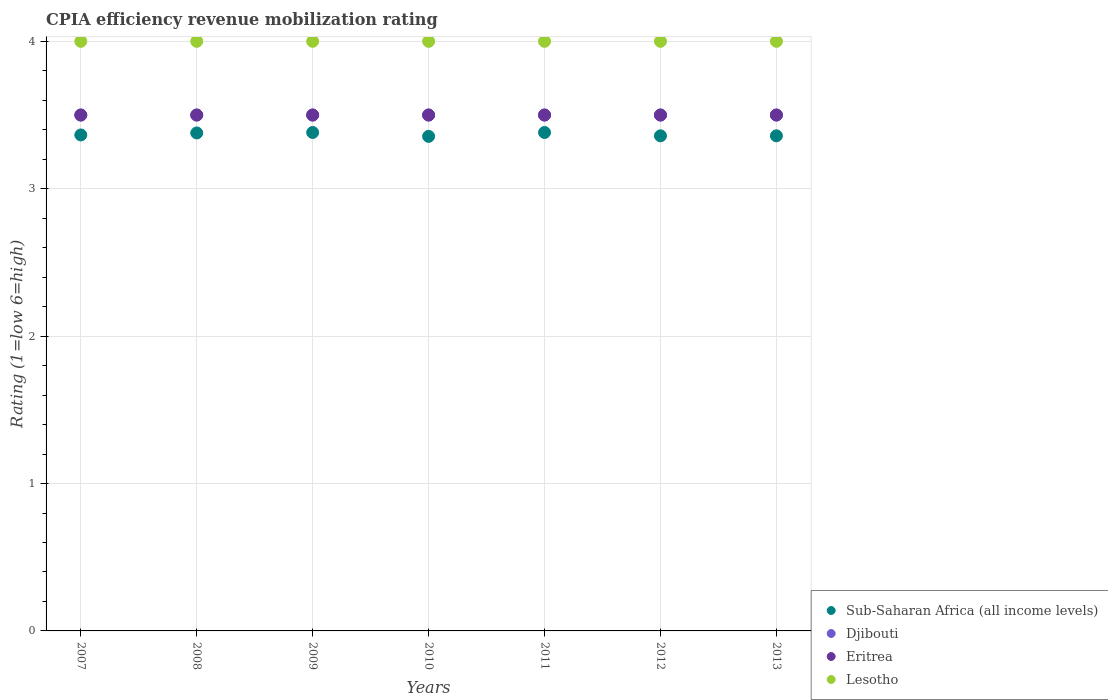How many different coloured dotlines are there?
Keep it short and to the point. 4. Is the number of dotlines equal to the number of legend labels?
Give a very brief answer. Yes. What is the CPIA rating in Djibouti in 2009?
Keep it short and to the point. 3.5. Across all years, what is the maximum CPIA rating in Lesotho?
Offer a very short reply. 4. What is the total CPIA rating in Lesotho in the graph?
Offer a very short reply. 28. What is the difference between the CPIA rating in Sub-Saharan Africa (all income levels) in 2008 and that in 2010?
Ensure brevity in your answer.  0.02. What is the average CPIA rating in Eritrea per year?
Offer a terse response. 3.5. In the year 2010, what is the difference between the CPIA rating in Sub-Saharan Africa (all income levels) and CPIA rating in Lesotho?
Your response must be concise. -0.64. In how many years, is the CPIA rating in Eritrea greater than 1.6?
Offer a very short reply. 7. Is the CPIA rating in Lesotho in 2010 less than that in 2013?
Offer a very short reply. No. Is the difference between the CPIA rating in Sub-Saharan Africa (all income levels) in 2010 and 2012 greater than the difference between the CPIA rating in Lesotho in 2010 and 2012?
Make the answer very short. No. What is the difference between the highest and the second highest CPIA rating in Eritrea?
Offer a very short reply. 0. In how many years, is the CPIA rating in Sub-Saharan Africa (all income levels) greater than the average CPIA rating in Sub-Saharan Africa (all income levels) taken over all years?
Offer a terse response. 3. Is the sum of the CPIA rating in Djibouti in 2012 and 2013 greater than the maximum CPIA rating in Eritrea across all years?
Offer a very short reply. Yes. Is it the case that in every year, the sum of the CPIA rating in Eritrea and CPIA rating in Djibouti  is greater than the CPIA rating in Sub-Saharan Africa (all income levels)?
Ensure brevity in your answer.  Yes. How many years are there in the graph?
Keep it short and to the point. 7. Are the values on the major ticks of Y-axis written in scientific E-notation?
Ensure brevity in your answer.  No. Does the graph contain any zero values?
Your answer should be very brief. No. Does the graph contain grids?
Give a very brief answer. Yes. Where does the legend appear in the graph?
Ensure brevity in your answer.  Bottom right. How are the legend labels stacked?
Make the answer very short. Vertical. What is the title of the graph?
Offer a very short reply. CPIA efficiency revenue mobilization rating. What is the label or title of the Y-axis?
Provide a succinct answer. Rating (1=low 6=high). What is the Rating (1=low 6=high) of Sub-Saharan Africa (all income levels) in 2007?
Give a very brief answer. 3.36. What is the Rating (1=low 6=high) in Djibouti in 2007?
Make the answer very short. 3.5. What is the Rating (1=low 6=high) in Lesotho in 2007?
Offer a very short reply. 4. What is the Rating (1=low 6=high) in Sub-Saharan Africa (all income levels) in 2008?
Give a very brief answer. 3.38. What is the Rating (1=low 6=high) in Djibouti in 2008?
Keep it short and to the point. 3.5. What is the Rating (1=low 6=high) in Sub-Saharan Africa (all income levels) in 2009?
Make the answer very short. 3.38. What is the Rating (1=low 6=high) of Eritrea in 2009?
Provide a short and direct response. 3.5. What is the Rating (1=low 6=high) in Sub-Saharan Africa (all income levels) in 2010?
Your answer should be compact. 3.36. What is the Rating (1=low 6=high) in Eritrea in 2010?
Your answer should be compact. 3.5. What is the Rating (1=low 6=high) in Lesotho in 2010?
Your response must be concise. 4. What is the Rating (1=low 6=high) in Sub-Saharan Africa (all income levels) in 2011?
Your answer should be compact. 3.38. What is the Rating (1=low 6=high) of Djibouti in 2011?
Your answer should be very brief. 3.5. What is the Rating (1=low 6=high) in Eritrea in 2011?
Your answer should be very brief. 3.5. What is the Rating (1=low 6=high) of Sub-Saharan Africa (all income levels) in 2012?
Offer a very short reply. 3.36. What is the Rating (1=low 6=high) in Eritrea in 2012?
Provide a short and direct response. 3.5. What is the Rating (1=low 6=high) of Lesotho in 2012?
Give a very brief answer. 4. What is the Rating (1=low 6=high) of Sub-Saharan Africa (all income levels) in 2013?
Offer a very short reply. 3.36. What is the Rating (1=low 6=high) in Lesotho in 2013?
Make the answer very short. 4. Across all years, what is the maximum Rating (1=low 6=high) in Sub-Saharan Africa (all income levels)?
Give a very brief answer. 3.38. Across all years, what is the maximum Rating (1=low 6=high) in Djibouti?
Your answer should be compact. 3.5. Across all years, what is the maximum Rating (1=low 6=high) of Eritrea?
Your response must be concise. 3.5. Across all years, what is the maximum Rating (1=low 6=high) of Lesotho?
Offer a very short reply. 4. Across all years, what is the minimum Rating (1=low 6=high) of Sub-Saharan Africa (all income levels)?
Your answer should be very brief. 3.36. Across all years, what is the minimum Rating (1=low 6=high) in Djibouti?
Make the answer very short. 3.5. Across all years, what is the minimum Rating (1=low 6=high) in Eritrea?
Your answer should be compact. 3.5. Across all years, what is the minimum Rating (1=low 6=high) in Lesotho?
Your answer should be compact. 4. What is the total Rating (1=low 6=high) in Sub-Saharan Africa (all income levels) in the graph?
Ensure brevity in your answer.  23.58. What is the total Rating (1=low 6=high) of Eritrea in the graph?
Provide a short and direct response. 24.5. What is the difference between the Rating (1=low 6=high) in Sub-Saharan Africa (all income levels) in 2007 and that in 2008?
Offer a terse response. -0.01. What is the difference between the Rating (1=low 6=high) of Djibouti in 2007 and that in 2008?
Make the answer very short. 0. What is the difference between the Rating (1=low 6=high) of Eritrea in 2007 and that in 2008?
Offer a very short reply. 0. What is the difference between the Rating (1=low 6=high) in Lesotho in 2007 and that in 2008?
Give a very brief answer. 0. What is the difference between the Rating (1=low 6=high) in Sub-Saharan Africa (all income levels) in 2007 and that in 2009?
Provide a short and direct response. -0.02. What is the difference between the Rating (1=low 6=high) of Lesotho in 2007 and that in 2009?
Keep it short and to the point. 0. What is the difference between the Rating (1=low 6=high) of Sub-Saharan Africa (all income levels) in 2007 and that in 2010?
Your answer should be compact. 0.01. What is the difference between the Rating (1=low 6=high) of Djibouti in 2007 and that in 2010?
Provide a succinct answer. 0. What is the difference between the Rating (1=low 6=high) of Eritrea in 2007 and that in 2010?
Provide a succinct answer. 0. What is the difference between the Rating (1=low 6=high) of Lesotho in 2007 and that in 2010?
Your answer should be compact. 0. What is the difference between the Rating (1=low 6=high) of Sub-Saharan Africa (all income levels) in 2007 and that in 2011?
Offer a very short reply. -0.02. What is the difference between the Rating (1=low 6=high) in Lesotho in 2007 and that in 2011?
Your response must be concise. 0. What is the difference between the Rating (1=low 6=high) in Sub-Saharan Africa (all income levels) in 2007 and that in 2012?
Provide a succinct answer. 0.01. What is the difference between the Rating (1=low 6=high) in Djibouti in 2007 and that in 2012?
Offer a terse response. 0. What is the difference between the Rating (1=low 6=high) of Lesotho in 2007 and that in 2012?
Offer a very short reply. 0. What is the difference between the Rating (1=low 6=high) of Sub-Saharan Africa (all income levels) in 2007 and that in 2013?
Provide a succinct answer. 0.01. What is the difference between the Rating (1=low 6=high) of Sub-Saharan Africa (all income levels) in 2008 and that in 2009?
Make the answer very short. -0. What is the difference between the Rating (1=low 6=high) in Djibouti in 2008 and that in 2009?
Make the answer very short. 0. What is the difference between the Rating (1=low 6=high) in Eritrea in 2008 and that in 2009?
Your response must be concise. 0. What is the difference between the Rating (1=low 6=high) of Sub-Saharan Africa (all income levels) in 2008 and that in 2010?
Make the answer very short. 0.02. What is the difference between the Rating (1=low 6=high) in Eritrea in 2008 and that in 2010?
Offer a very short reply. 0. What is the difference between the Rating (1=low 6=high) of Lesotho in 2008 and that in 2010?
Give a very brief answer. 0. What is the difference between the Rating (1=low 6=high) of Sub-Saharan Africa (all income levels) in 2008 and that in 2011?
Keep it short and to the point. -0. What is the difference between the Rating (1=low 6=high) of Eritrea in 2008 and that in 2011?
Make the answer very short. 0. What is the difference between the Rating (1=low 6=high) of Sub-Saharan Africa (all income levels) in 2008 and that in 2012?
Provide a succinct answer. 0.02. What is the difference between the Rating (1=low 6=high) in Eritrea in 2008 and that in 2012?
Keep it short and to the point. 0. What is the difference between the Rating (1=low 6=high) in Lesotho in 2008 and that in 2012?
Give a very brief answer. 0. What is the difference between the Rating (1=low 6=high) of Sub-Saharan Africa (all income levels) in 2008 and that in 2013?
Make the answer very short. 0.02. What is the difference between the Rating (1=low 6=high) of Djibouti in 2008 and that in 2013?
Keep it short and to the point. 0. What is the difference between the Rating (1=low 6=high) of Lesotho in 2008 and that in 2013?
Ensure brevity in your answer.  0. What is the difference between the Rating (1=low 6=high) in Sub-Saharan Africa (all income levels) in 2009 and that in 2010?
Give a very brief answer. 0.03. What is the difference between the Rating (1=low 6=high) in Lesotho in 2009 and that in 2010?
Provide a short and direct response. 0. What is the difference between the Rating (1=low 6=high) in Sub-Saharan Africa (all income levels) in 2009 and that in 2012?
Give a very brief answer. 0.02. What is the difference between the Rating (1=low 6=high) of Lesotho in 2009 and that in 2012?
Offer a terse response. 0. What is the difference between the Rating (1=low 6=high) of Sub-Saharan Africa (all income levels) in 2009 and that in 2013?
Provide a short and direct response. 0.02. What is the difference between the Rating (1=low 6=high) in Eritrea in 2009 and that in 2013?
Your response must be concise. 0. What is the difference between the Rating (1=low 6=high) in Lesotho in 2009 and that in 2013?
Keep it short and to the point. 0. What is the difference between the Rating (1=low 6=high) of Sub-Saharan Africa (all income levels) in 2010 and that in 2011?
Offer a terse response. -0.03. What is the difference between the Rating (1=low 6=high) of Sub-Saharan Africa (all income levels) in 2010 and that in 2012?
Offer a very short reply. -0. What is the difference between the Rating (1=low 6=high) of Djibouti in 2010 and that in 2012?
Give a very brief answer. 0. What is the difference between the Rating (1=low 6=high) in Eritrea in 2010 and that in 2012?
Your answer should be very brief. 0. What is the difference between the Rating (1=low 6=high) in Sub-Saharan Africa (all income levels) in 2010 and that in 2013?
Provide a succinct answer. -0. What is the difference between the Rating (1=low 6=high) of Lesotho in 2010 and that in 2013?
Provide a succinct answer. 0. What is the difference between the Rating (1=low 6=high) in Sub-Saharan Africa (all income levels) in 2011 and that in 2012?
Make the answer very short. 0.02. What is the difference between the Rating (1=low 6=high) of Djibouti in 2011 and that in 2012?
Make the answer very short. 0. What is the difference between the Rating (1=low 6=high) in Eritrea in 2011 and that in 2012?
Your answer should be compact. 0. What is the difference between the Rating (1=low 6=high) of Sub-Saharan Africa (all income levels) in 2011 and that in 2013?
Offer a terse response. 0.02. What is the difference between the Rating (1=low 6=high) of Djibouti in 2011 and that in 2013?
Your response must be concise. 0. What is the difference between the Rating (1=low 6=high) of Lesotho in 2011 and that in 2013?
Provide a short and direct response. 0. What is the difference between the Rating (1=low 6=high) of Sub-Saharan Africa (all income levels) in 2012 and that in 2013?
Your response must be concise. 0. What is the difference between the Rating (1=low 6=high) of Djibouti in 2012 and that in 2013?
Ensure brevity in your answer.  0. What is the difference between the Rating (1=low 6=high) of Lesotho in 2012 and that in 2013?
Offer a very short reply. 0. What is the difference between the Rating (1=low 6=high) in Sub-Saharan Africa (all income levels) in 2007 and the Rating (1=low 6=high) in Djibouti in 2008?
Offer a very short reply. -0.14. What is the difference between the Rating (1=low 6=high) in Sub-Saharan Africa (all income levels) in 2007 and the Rating (1=low 6=high) in Eritrea in 2008?
Ensure brevity in your answer.  -0.14. What is the difference between the Rating (1=low 6=high) of Sub-Saharan Africa (all income levels) in 2007 and the Rating (1=low 6=high) of Lesotho in 2008?
Your answer should be very brief. -0.64. What is the difference between the Rating (1=low 6=high) in Djibouti in 2007 and the Rating (1=low 6=high) in Lesotho in 2008?
Provide a short and direct response. -0.5. What is the difference between the Rating (1=low 6=high) of Eritrea in 2007 and the Rating (1=low 6=high) of Lesotho in 2008?
Provide a succinct answer. -0.5. What is the difference between the Rating (1=low 6=high) in Sub-Saharan Africa (all income levels) in 2007 and the Rating (1=low 6=high) in Djibouti in 2009?
Your response must be concise. -0.14. What is the difference between the Rating (1=low 6=high) in Sub-Saharan Africa (all income levels) in 2007 and the Rating (1=low 6=high) in Eritrea in 2009?
Ensure brevity in your answer.  -0.14. What is the difference between the Rating (1=low 6=high) of Sub-Saharan Africa (all income levels) in 2007 and the Rating (1=low 6=high) of Lesotho in 2009?
Your answer should be very brief. -0.64. What is the difference between the Rating (1=low 6=high) in Djibouti in 2007 and the Rating (1=low 6=high) in Eritrea in 2009?
Offer a very short reply. 0. What is the difference between the Rating (1=low 6=high) in Djibouti in 2007 and the Rating (1=low 6=high) in Lesotho in 2009?
Keep it short and to the point. -0.5. What is the difference between the Rating (1=low 6=high) of Sub-Saharan Africa (all income levels) in 2007 and the Rating (1=low 6=high) of Djibouti in 2010?
Your answer should be compact. -0.14. What is the difference between the Rating (1=low 6=high) of Sub-Saharan Africa (all income levels) in 2007 and the Rating (1=low 6=high) of Eritrea in 2010?
Give a very brief answer. -0.14. What is the difference between the Rating (1=low 6=high) in Sub-Saharan Africa (all income levels) in 2007 and the Rating (1=low 6=high) in Lesotho in 2010?
Ensure brevity in your answer.  -0.64. What is the difference between the Rating (1=low 6=high) of Djibouti in 2007 and the Rating (1=low 6=high) of Eritrea in 2010?
Your response must be concise. 0. What is the difference between the Rating (1=low 6=high) of Eritrea in 2007 and the Rating (1=low 6=high) of Lesotho in 2010?
Your response must be concise. -0.5. What is the difference between the Rating (1=low 6=high) in Sub-Saharan Africa (all income levels) in 2007 and the Rating (1=low 6=high) in Djibouti in 2011?
Offer a terse response. -0.14. What is the difference between the Rating (1=low 6=high) of Sub-Saharan Africa (all income levels) in 2007 and the Rating (1=low 6=high) of Eritrea in 2011?
Your answer should be very brief. -0.14. What is the difference between the Rating (1=low 6=high) in Sub-Saharan Africa (all income levels) in 2007 and the Rating (1=low 6=high) in Lesotho in 2011?
Keep it short and to the point. -0.64. What is the difference between the Rating (1=low 6=high) in Djibouti in 2007 and the Rating (1=low 6=high) in Eritrea in 2011?
Keep it short and to the point. 0. What is the difference between the Rating (1=low 6=high) of Djibouti in 2007 and the Rating (1=low 6=high) of Lesotho in 2011?
Keep it short and to the point. -0.5. What is the difference between the Rating (1=low 6=high) of Sub-Saharan Africa (all income levels) in 2007 and the Rating (1=low 6=high) of Djibouti in 2012?
Keep it short and to the point. -0.14. What is the difference between the Rating (1=low 6=high) of Sub-Saharan Africa (all income levels) in 2007 and the Rating (1=low 6=high) of Eritrea in 2012?
Your answer should be compact. -0.14. What is the difference between the Rating (1=low 6=high) of Sub-Saharan Africa (all income levels) in 2007 and the Rating (1=low 6=high) of Lesotho in 2012?
Your answer should be very brief. -0.64. What is the difference between the Rating (1=low 6=high) of Djibouti in 2007 and the Rating (1=low 6=high) of Eritrea in 2012?
Your answer should be very brief. 0. What is the difference between the Rating (1=low 6=high) in Djibouti in 2007 and the Rating (1=low 6=high) in Lesotho in 2012?
Provide a succinct answer. -0.5. What is the difference between the Rating (1=low 6=high) in Eritrea in 2007 and the Rating (1=low 6=high) in Lesotho in 2012?
Ensure brevity in your answer.  -0.5. What is the difference between the Rating (1=low 6=high) of Sub-Saharan Africa (all income levels) in 2007 and the Rating (1=low 6=high) of Djibouti in 2013?
Your response must be concise. -0.14. What is the difference between the Rating (1=low 6=high) in Sub-Saharan Africa (all income levels) in 2007 and the Rating (1=low 6=high) in Eritrea in 2013?
Give a very brief answer. -0.14. What is the difference between the Rating (1=low 6=high) in Sub-Saharan Africa (all income levels) in 2007 and the Rating (1=low 6=high) in Lesotho in 2013?
Provide a succinct answer. -0.64. What is the difference between the Rating (1=low 6=high) of Djibouti in 2007 and the Rating (1=low 6=high) of Lesotho in 2013?
Provide a short and direct response. -0.5. What is the difference between the Rating (1=low 6=high) in Eritrea in 2007 and the Rating (1=low 6=high) in Lesotho in 2013?
Provide a short and direct response. -0.5. What is the difference between the Rating (1=low 6=high) in Sub-Saharan Africa (all income levels) in 2008 and the Rating (1=low 6=high) in Djibouti in 2009?
Keep it short and to the point. -0.12. What is the difference between the Rating (1=low 6=high) of Sub-Saharan Africa (all income levels) in 2008 and the Rating (1=low 6=high) of Eritrea in 2009?
Provide a short and direct response. -0.12. What is the difference between the Rating (1=low 6=high) of Sub-Saharan Africa (all income levels) in 2008 and the Rating (1=low 6=high) of Lesotho in 2009?
Offer a very short reply. -0.62. What is the difference between the Rating (1=low 6=high) of Djibouti in 2008 and the Rating (1=low 6=high) of Eritrea in 2009?
Your response must be concise. 0. What is the difference between the Rating (1=low 6=high) in Djibouti in 2008 and the Rating (1=low 6=high) in Lesotho in 2009?
Your response must be concise. -0.5. What is the difference between the Rating (1=low 6=high) in Sub-Saharan Africa (all income levels) in 2008 and the Rating (1=low 6=high) in Djibouti in 2010?
Your answer should be very brief. -0.12. What is the difference between the Rating (1=low 6=high) of Sub-Saharan Africa (all income levels) in 2008 and the Rating (1=low 6=high) of Eritrea in 2010?
Your answer should be compact. -0.12. What is the difference between the Rating (1=low 6=high) in Sub-Saharan Africa (all income levels) in 2008 and the Rating (1=low 6=high) in Lesotho in 2010?
Give a very brief answer. -0.62. What is the difference between the Rating (1=low 6=high) in Eritrea in 2008 and the Rating (1=low 6=high) in Lesotho in 2010?
Ensure brevity in your answer.  -0.5. What is the difference between the Rating (1=low 6=high) in Sub-Saharan Africa (all income levels) in 2008 and the Rating (1=low 6=high) in Djibouti in 2011?
Your answer should be compact. -0.12. What is the difference between the Rating (1=low 6=high) of Sub-Saharan Africa (all income levels) in 2008 and the Rating (1=low 6=high) of Eritrea in 2011?
Offer a very short reply. -0.12. What is the difference between the Rating (1=low 6=high) of Sub-Saharan Africa (all income levels) in 2008 and the Rating (1=low 6=high) of Lesotho in 2011?
Your response must be concise. -0.62. What is the difference between the Rating (1=low 6=high) of Djibouti in 2008 and the Rating (1=low 6=high) of Eritrea in 2011?
Your answer should be very brief. 0. What is the difference between the Rating (1=low 6=high) of Sub-Saharan Africa (all income levels) in 2008 and the Rating (1=low 6=high) of Djibouti in 2012?
Give a very brief answer. -0.12. What is the difference between the Rating (1=low 6=high) in Sub-Saharan Africa (all income levels) in 2008 and the Rating (1=low 6=high) in Eritrea in 2012?
Your answer should be very brief. -0.12. What is the difference between the Rating (1=low 6=high) of Sub-Saharan Africa (all income levels) in 2008 and the Rating (1=low 6=high) of Lesotho in 2012?
Your response must be concise. -0.62. What is the difference between the Rating (1=low 6=high) of Djibouti in 2008 and the Rating (1=low 6=high) of Eritrea in 2012?
Your answer should be very brief. 0. What is the difference between the Rating (1=low 6=high) in Djibouti in 2008 and the Rating (1=low 6=high) in Lesotho in 2012?
Your response must be concise. -0.5. What is the difference between the Rating (1=low 6=high) in Eritrea in 2008 and the Rating (1=low 6=high) in Lesotho in 2012?
Provide a succinct answer. -0.5. What is the difference between the Rating (1=low 6=high) in Sub-Saharan Africa (all income levels) in 2008 and the Rating (1=low 6=high) in Djibouti in 2013?
Provide a short and direct response. -0.12. What is the difference between the Rating (1=low 6=high) in Sub-Saharan Africa (all income levels) in 2008 and the Rating (1=low 6=high) in Eritrea in 2013?
Ensure brevity in your answer.  -0.12. What is the difference between the Rating (1=low 6=high) of Sub-Saharan Africa (all income levels) in 2008 and the Rating (1=low 6=high) of Lesotho in 2013?
Ensure brevity in your answer.  -0.62. What is the difference between the Rating (1=low 6=high) of Djibouti in 2008 and the Rating (1=low 6=high) of Eritrea in 2013?
Provide a succinct answer. 0. What is the difference between the Rating (1=low 6=high) in Sub-Saharan Africa (all income levels) in 2009 and the Rating (1=low 6=high) in Djibouti in 2010?
Offer a terse response. -0.12. What is the difference between the Rating (1=low 6=high) of Sub-Saharan Africa (all income levels) in 2009 and the Rating (1=low 6=high) of Eritrea in 2010?
Keep it short and to the point. -0.12. What is the difference between the Rating (1=low 6=high) of Sub-Saharan Africa (all income levels) in 2009 and the Rating (1=low 6=high) of Lesotho in 2010?
Your answer should be very brief. -0.62. What is the difference between the Rating (1=low 6=high) in Djibouti in 2009 and the Rating (1=low 6=high) in Eritrea in 2010?
Your response must be concise. 0. What is the difference between the Rating (1=low 6=high) of Djibouti in 2009 and the Rating (1=low 6=high) of Lesotho in 2010?
Your response must be concise. -0.5. What is the difference between the Rating (1=low 6=high) in Eritrea in 2009 and the Rating (1=low 6=high) in Lesotho in 2010?
Your response must be concise. -0.5. What is the difference between the Rating (1=low 6=high) in Sub-Saharan Africa (all income levels) in 2009 and the Rating (1=low 6=high) in Djibouti in 2011?
Provide a succinct answer. -0.12. What is the difference between the Rating (1=low 6=high) of Sub-Saharan Africa (all income levels) in 2009 and the Rating (1=low 6=high) of Eritrea in 2011?
Your answer should be compact. -0.12. What is the difference between the Rating (1=low 6=high) in Sub-Saharan Africa (all income levels) in 2009 and the Rating (1=low 6=high) in Lesotho in 2011?
Your response must be concise. -0.62. What is the difference between the Rating (1=low 6=high) of Djibouti in 2009 and the Rating (1=low 6=high) of Eritrea in 2011?
Give a very brief answer. 0. What is the difference between the Rating (1=low 6=high) of Sub-Saharan Africa (all income levels) in 2009 and the Rating (1=low 6=high) of Djibouti in 2012?
Provide a short and direct response. -0.12. What is the difference between the Rating (1=low 6=high) in Sub-Saharan Africa (all income levels) in 2009 and the Rating (1=low 6=high) in Eritrea in 2012?
Your answer should be very brief. -0.12. What is the difference between the Rating (1=low 6=high) in Sub-Saharan Africa (all income levels) in 2009 and the Rating (1=low 6=high) in Lesotho in 2012?
Give a very brief answer. -0.62. What is the difference between the Rating (1=low 6=high) in Djibouti in 2009 and the Rating (1=low 6=high) in Lesotho in 2012?
Your answer should be compact. -0.5. What is the difference between the Rating (1=low 6=high) in Eritrea in 2009 and the Rating (1=low 6=high) in Lesotho in 2012?
Ensure brevity in your answer.  -0.5. What is the difference between the Rating (1=low 6=high) in Sub-Saharan Africa (all income levels) in 2009 and the Rating (1=low 6=high) in Djibouti in 2013?
Your answer should be compact. -0.12. What is the difference between the Rating (1=low 6=high) of Sub-Saharan Africa (all income levels) in 2009 and the Rating (1=low 6=high) of Eritrea in 2013?
Keep it short and to the point. -0.12. What is the difference between the Rating (1=low 6=high) of Sub-Saharan Africa (all income levels) in 2009 and the Rating (1=low 6=high) of Lesotho in 2013?
Make the answer very short. -0.62. What is the difference between the Rating (1=low 6=high) in Djibouti in 2009 and the Rating (1=low 6=high) in Eritrea in 2013?
Provide a short and direct response. 0. What is the difference between the Rating (1=low 6=high) of Djibouti in 2009 and the Rating (1=low 6=high) of Lesotho in 2013?
Offer a very short reply. -0.5. What is the difference between the Rating (1=low 6=high) of Eritrea in 2009 and the Rating (1=low 6=high) of Lesotho in 2013?
Ensure brevity in your answer.  -0.5. What is the difference between the Rating (1=low 6=high) of Sub-Saharan Africa (all income levels) in 2010 and the Rating (1=low 6=high) of Djibouti in 2011?
Your response must be concise. -0.14. What is the difference between the Rating (1=low 6=high) in Sub-Saharan Africa (all income levels) in 2010 and the Rating (1=low 6=high) in Eritrea in 2011?
Provide a short and direct response. -0.14. What is the difference between the Rating (1=low 6=high) in Sub-Saharan Africa (all income levels) in 2010 and the Rating (1=low 6=high) in Lesotho in 2011?
Offer a very short reply. -0.64. What is the difference between the Rating (1=low 6=high) in Eritrea in 2010 and the Rating (1=low 6=high) in Lesotho in 2011?
Ensure brevity in your answer.  -0.5. What is the difference between the Rating (1=low 6=high) of Sub-Saharan Africa (all income levels) in 2010 and the Rating (1=low 6=high) of Djibouti in 2012?
Your answer should be compact. -0.14. What is the difference between the Rating (1=low 6=high) of Sub-Saharan Africa (all income levels) in 2010 and the Rating (1=low 6=high) of Eritrea in 2012?
Give a very brief answer. -0.14. What is the difference between the Rating (1=low 6=high) of Sub-Saharan Africa (all income levels) in 2010 and the Rating (1=low 6=high) of Lesotho in 2012?
Make the answer very short. -0.64. What is the difference between the Rating (1=low 6=high) in Djibouti in 2010 and the Rating (1=low 6=high) in Eritrea in 2012?
Your response must be concise. 0. What is the difference between the Rating (1=low 6=high) in Djibouti in 2010 and the Rating (1=low 6=high) in Lesotho in 2012?
Give a very brief answer. -0.5. What is the difference between the Rating (1=low 6=high) in Eritrea in 2010 and the Rating (1=low 6=high) in Lesotho in 2012?
Your answer should be very brief. -0.5. What is the difference between the Rating (1=low 6=high) of Sub-Saharan Africa (all income levels) in 2010 and the Rating (1=low 6=high) of Djibouti in 2013?
Provide a short and direct response. -0.14. What is the difference between the Rating (1=low 6=high) in Sub-Saharan Africa (all income levels) in 2010 and the Rating (1=low 6=high) in Eritrea in 2013?
Your answer should be very brief. -0.14. What is the difference between the Rating (1=low 6=high) of Sub-Saharan Africa (all income levels) in 2010 and the Rating (1=low 6=high) of Lesotho in 2013?
Give a very brief answer. -0.64. What is the difference between the Rating (1=low 6=high) in Djibouti in 2010 and the Rating (1=low 6=high) in Lesotho in 2013?
Make the answer very short. -0.5. What is the difference between the Rating (1=low 6=high) of Sub-Saharan Africa (all income levels) in 2011 and the Rating (1=low 6=high) of Djibouti in 2012?
Make the answer very short. -0.12. What is the difference between the Rating (1=low 6=high) of Sub-Saharan Africa (all income levels) in 2011 and the Rating (1=low 6=high) of Eritrea in 2012?
Give a very brief answer. -0.12. What is the difference between the Rating (1=low 6=high) of Sub-Saharan Africa (all income levels) in 2011 and the Rating (1=low 6=high) of Lesotho in 2012?
Offer a terse response. -0.62. What is the difference between the Rating (1=low 6=high) in Djibouti in 2011 and the Rating (1=low 6=high) in Eritrea in 2012?
Give a very brief answer. 0. What is the difference between the Rating (1=low 6=high) of Djibouti in 2011 and the Rating (1=low 6=high) of Lesotho in 2012?
Your answer should be compact. -0.5. What is the difference between the Rating (1=low 6=high) in Eritrea in 2011 and the Rating (1=low 6=high) in Lesotho in 2012?
Provide a succinct answer. -0.5. What is the difference between the Rating (1=low 6=high) in Sub-Saharan Africa (all income levels) in 2011 and the Rating (1=low 6=high) in Djibouti in 2013?
Your answer should be very brief. -0.12. What is the difference between the Rating (1=low 6=high) of Sub-Saharan Africa (all income levels) in 2011 and the Rating (1=low 6=high) of Eritrea in 2013?
Ensure brevity in your answer.  -0.12. What is the difference between the Rating (1=low 6=high) in Sub-Saharan Africa (all income levels) in 2011 and the Rating (1=low 6=high) in Lesotho in 2013?
Offer a terse response. -0.62. What is the difference between the Rating (1=low 6=high) of Djibouti in 2011 and the Rating (1=low 6=high) of Eritrea in 2013?
Your answer should be very brief. 0. What is the difference between the Rating (1=low 6=high) in Eritrea in 2011 and the Rating (1=low 6=high) in Lesotho in 2013?
Make the answer very short. -0.5. What is the difference between the Rating (1=low 6=high) in Sub-Saharan Africa (all income levels) in 2012 and the Rating (1=low 6=high) in Djibouti in 2013?
Keep it short and to the point. -0.14. What is the difference between the Rating (1=low 6=high) of Sub-Saharan Africa (all income levels) in 2012 and the Rating (1=low 6=high) of Eritrea in 2013?
Your answer should be very brief. -0.14. What is the difference between the Rating (1=low 6=high) of Sub-Saharan Africa (all income levels) in 2012 and the Rating (1=low 6=high) of Lesotho in 2013?
Provide a succinct answer. -0.64. What is the difference between the Rating (1=low 6=high) in Djibouti in 2012 and the Rating (1=low 6=high) in Eritrea in 2013?
Offer a terse response. 0. What is the average Rating (1=low 6=high) in Sub-Saharan Africa (all income levels) per year?
Provide a succinct answer. 3.37. What is the average Rating (1=low 6=high) of Djibouti per year?
Your answer should be very brief. 3.5. What is the average Rating (1=low 6=high) of Eritrea per year?
Give a very brief answer. 3.5. What is the average Rating (1=low 6=high) of Lesotho per year?
Keep it short and to the point. 4. In the year 2007, what is the difference between the Rating (1=low 6=high) of Sub-Saharan Africa (all income levels) and Rating (1=low 6=high) of Djibouti?
Ensure brevity in your answer.  -0.14. In the year 2007, what is the difference between the Rating (1=low 6=high) of Sub-Saharan Africa (all income levels) and Rating (1=low 6=high) of Eritrea?
Your answer should be compact. -0.14. In the year 2007, what is the difference between the Rating (1=low 6=high) of Sub-Saharan Africa (all income levels) and Rating (1=low 6=high) of Lesotho?
Ensure brevity in your answer.  -0.64. In the year 2007, what is the difference between the Rating (1=low 6=high) of Eritrea and Rating (1=low 6=high) of Lesotho?
Your response must be concise. -0.5. In the year 2008, what is the difference between the Rating (1=low 6=high) of Sub-Saharan Africa (all income levels) and Rating (1=low 6=high) of Djibouti?
Your answer should be compact. -0.12. In the year 2008, what is the difference between the Rating (1=low 6=high) of Sub-Saharan Africa (all income levels) and Rating (1=low 6=high) of Eritrea?
Offer a terse response. -0.12. In the year 2008, what is the difference between the Rating (1=low 6=high) in Sub-Saharan Africa (all income levels) and Rating (1=low 6=high) in Lesotho?
Provide a succinct answer. -0.62. In the year 2008, what is the difference between the Rating (1=low 6=high) in Djibouti and Rating (1=low 6=high) in Lesotho?
Keep it short and to the point. -0.5. In the year 2009, what is the difference between the Rating (1=low 6=high) in Sub-Saharan Africa (all income levels) and Rating (1=low 6=high) in Djibouti?
Your answer should be very brief. -0.12. In the year 2009, what is the difference between the Rating (1=low 6=high) of Sub-Saharan Africa (all income levels) and Rating (1=low 6=high) of Eritrea?
Offer a very short reply. -0.12. In the year 2009, what is the difference between the Rating (1=low 6=high) of Sub-Saharan Africa (all income levels) and Rating (1=low 6=high) of Lesotho?
Ensure brevity in your answer.  -0.62. In the year 2010, what is the difference between the Rating (1=low 6=high) of Sub-Saharan Africa (all income levels) and Rating (1=low 6=high) of Djibouti?
Offer a terse response. -0.14. In the year 2010, what is the difference between the Rating (1=low 6=high) of Sub-Saharan Africa (all income levels) and Rating (1=low 6=high) of Eritrea?
Ensure brevity in your answer.  -0.14. In the year 2010, what is the difference between the Rating (1=low 6=high) in Sub-Saharan Africa (all income levels) and Rating (1=low 6=high) in Lesotho?
Your answer should be very brief. -0.64. In the year 2010, what is the difference between the Rating (1=low 6=high) in Djibouti and Rating (1=low 6=high) in Eritrea?
Your response must be concise. 0. In the year 2010, what is the difference between the Rating (1=low 6=high) of Djibouti and Rating (1=low 6=high) of Lesotho?
Offer a very short reply. -0.5. In the year 2010, what is the difference between the Rating (1=low 6=high) in Eritrea and Rating (1=low 6=high) in Lesotho?
Your answer should be compact. -0.5. In the year 2011, what is the difference between the Rating (1=low 6=high) in Sub-Saharan Africa (all income levels) and Rating (1=low 6=high) in Djibouti?
Your response must be concise. -0.12. In the year 2011, what is the difference between the Rating (1=low 6=high) in Sub-Saharan Africa (all income levels) and Rating (1=low 6=high) in Eritrea?
Keep it short and to the point. -0.12. In the year 2011, what is the difference between the Rating (1=low 6=high) of Sub-Saharan Africa (all income levels) and Rating (1=low 6=high) of Lesotho?
Your response must be concise. -0.62. In the year 2012, what is the difference between the Rating (1=low 6=high) of Sub-Saharan Africa (all income levels) and Rating (1=low 6=high) of Djibouti?
Offer a very short reply. -0.14. In the year 2012, what is the difference between the Rating (1=low 6=high) in Sub-Saharan Africa (all income levels) and Rating (1=low 6=high) in Eritrea?
Your response must be concise. -0.14. In the year 2012, what is the difference between the Rating (1=low 6=high) in Sub-Saharan Africa (all income levels) and Rating (1=low 6=high) in Lesotho?
Provide a short and direct response. -0.64. In the year 2012, what is the difference between the Rating (1=low 6=high) in Eritrea and Rating (1=low 6=high) in Lesotho?
Offer a terse response. -0.5. In the year 2013, what is the difference between the Rating (1=low 6=high) of Sub-Saharan Africa (all income levels) and Rating (1=low 6=high) of Djibouti?
Provide a succinct answer. -0.14. In the year 2013, what is the difference between the Rating (1=low 6=high) in Sub-Saharan Africa (all income levels) and Rating (1=low 6=high) in Eritrea?
Provide a short and direct response. -0.14. In the year 2013, what is the difference between the Rating (1=low 6=high) in Sub-Saharan Africa (all income levels) and Rating (1=low 6=high) in Lesotho?
Your answer should be compact. -0.64. In the year 2013, what is the difference between the Rating (1=low 6=high) in Djibouti and Rating (1=low 6=high) in Lesotho?
Make the answer very short. -0.5. In the year 2013, what is the difference between the Rating (1=low 6=high) in Eritrea and Rating (1=low 6=high) in Lesotho?
Ensure brevity in your answer.  -0.5. What is the ratio of the Rating (1=low 6=high) in Djibouti in 2007 to that in 2008?
Offer a very short reply. 1. What is the ratio of the Rating (1=low 6=high) in Eritrea in 2007 to that in 2008?
Your answer should be very brief. 1. What is the ratio of the Rating (1=low 6=high) in Lesotho in 2007 to that in 2008?
Your answer should be compact. 1. What is the ratio of the Rating (1=low 6=high) of Djibouti in 2007 to that in 2009?
Provide a short and direct response. 1. What is the ratio of the Rating (1=low 6=high) of Sub-Saharan Africa (all income levels) in 2007 to that in 2010?
Make the answer very short. 1. What is the ratio of the Rating (1=low 6=high) in Eritrea in 2007 to that in 2010?
Your answer should be compact. 1. What is the ratio of the Rating (1=low 6=high) of Lesotho in 2007 to that in 2010?
Provide a short and direct response. 1. What is the ratio of the Rating (1=low 6=high) of Sub-Saharan Africa (all income levels) in 2007 to that in 2011?
Provide a succinct answer. 1. What is the ratio of the Rating (1=low 6=high) of Djibouti in 2007 to that in 2011?
Ensure brevity in your answer.  1. What is the ratio of the Rating (1=low 6=high) of Sub-Saharan Africa (all income levels) in 2007 to that in 2012?
Offer a terse response. 1. What is the ratio of the Rating (1=low 6=high) in Djibouti in 2007 to that in 2013?
Give a very brief answer. 1. What is the ratio of the Rating (1=low 6=high) of Eritrea in 2007 to that in 2013?
Keep it short and to the point. 1. What is the ratio of the Rating (1=low 6=high) in Lesotho in 2007 to that in 2013?
Your response must be concise. 1. What is the ratio of the Rating (1=low 6=high) of Djibouti in 2008 to that in 2009?
Your answer should be very brief. 1. What is the ratio of the Rating (1=low 6=high) of Lesotho in 2008 to that in 2009?
Ensure brevity in your answer.  1. What is the ratio of the Rating (1=low 6=high) in Sub-Saharan Africa (all income levels) in 2008 to that in 2010?
Keep it short and to the point. 1.01. What is the ratio of the Rating (1=low 6=high) of Djibouti in 2008 to that in 2010?
Make the answer very short. 1. What is the ratio of the Rating (1=low 6=high) of Lesotho in 2008 to that in 2010?
Make the answer very short. 1. What is the ratio of the Rating (1=low 6=high) of Djibouti in 2008 to that in 2011?
Offer a terse response. 1. What is the ratio of the Rating (1=low 6=high) of Eritrea in 2008 to that in 2011?
Keep it short and to the point. 1. What is the ratio of the Rating (1=low 6=high) of Djibouti in 2008 to that in 2012?
Offer a very short reply. 1. What is the ratio of the Rating (1=low 6=high) in Eritrea in 2008 to that in 2012?
Provide a succinct answer. 1. What is the ratio of the Rating (1=low 6=high) of Lesotho in 2008 to that in 2012?
Your answer should be compact. 1. What is the ratio of the Rating (1=low 6=high) of Sub-Saharan Africa (all income levels) in 2008 to that in 2013?
Ensure brevity in your answer.  1.01. What is the ratio of the Rating (1=low 6=high) in Djibouti in 2008 to that in 2013?
Your answer should be compact. 1. What is the ratio of the Rating (1=low 6=high) of Lesotho in 2008 to that in 2013?
Your answer should be compact. 1. What is the ratio of the Rating (1=low 6=high) of Eritrea in 2009 to that in 2010?
Offer a terse response. 1. What is the ratio of the Rating (1=low 6=high) of Sub-Saharan Africa (all income levels) in 2009 to that in 2011?
Keep it short and to the point. 1. What is the ratio of the Rating (1=low 6=high) in Lesotho in 2009 to that in 2011?
Provide a succinct answer. 1. What is the ratio of the Rating (1=low 6=high) in Djibouti in 2009 to that in 2012?
Provide a succinct answer. 1. What is the ratio of the Rating (1=low 6=high) in Eritrea in 2009 to that in 2012?
Offer a terse response. 1. What is the ratio of the Rating (1=low 6=high) in Djibouti in 2009 to that in 2013?
Your answer should be very brief. 1. What is the ratio of the Rating (1=low 6=high) of Lesotho in 2009 to that in 2013?
Offer a terse response. 1. What is the ratio of the Rating (1=low 6=high) in Sub-Saharan Africa (all income levels) in 2010 to that in 2011?
Make the answer very short. 0.99. What is the ratio of the Rating (1=low 6=high) of Djibouti in 2010 to that in 2011?
Make the answer very short. 1. What is the ratio of the Rating (1=low 6=high) of Eritrea in 2010 to that in 2011?
Give a very brief answer. 1. What is the ratio of the Rating (1=low 6=high) of Sub-Saharan Africa (all income levels) in 2010 to that in 2012?
Keep it short and to the point. 1. What is the ratio of the Rating (1=low 6=high) in Djibouti in 2010 to that in 2012?
Offer a very short reply. 1. What is the ratio of the Rating (1=low 6=high) in Lesotho in 2010 to that in 2012?
Your answer should be compact. 1. What is the ratio of the Rating (1=low 6=high) in Djibouti in 2010 to that in 2013?
Offer a terse response. 1. What is the ratio of the Rating (1=low 6=high) of Sub-Saharan Africa (all income levels) in 2011 to that in 2012?
Your answer should be very brief. 1.01. What is the ratio of the Rating (1=low 6=high) of Djibouti in 2011 to that in 2012?
Your answer should be compact. 1. What is the ratio of the Rating (1=low 6=high) in Djibouti in 2011 to that in 2013?
Your response must be concise. 1. What is the ratio of the Rating (1=low 6=high) in Eritrea in 2012 to that in 2013?
Offer a very short reply. 1. What is the difference between the highest and the second highest Rating (1=low 6=high) of Sub-Saharan Africa (all income levels)?
Your response must be concise. 0. What is the difference between the highest and the second highest Rating (1=low 6=high) of Djibouti?
Provide a succinct answer. 0. What is the difference between the highest and the second highest Rating (1=low 6=high) of Lesotho?
Make the answer very short. 0. What is the difference between the highest and the lowest Rating (1=low 6=high) in Sub-Saharan Africa (all income levels)?
Ensure brevity in your answer.  0.03. What is the difference between the highest and the lowest Rating (1=low 6=high) of Djibouti?
Keep it short and to the point. 0. What is the difference between the highest and the lowest Rating (1=low 6=high) of Eritrea?
Provide a succinct answer. 0. What is the difference between the highest and the lowest Rating (1=low 6=high) in Lesotho?
Provide a short and direct response. 0. 